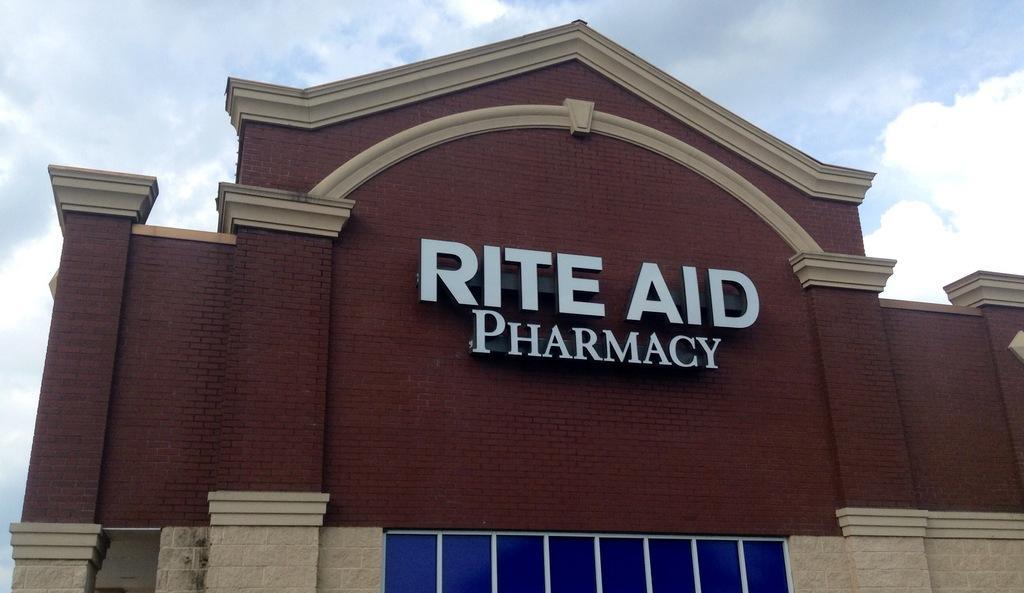Could you give a brief overview of what you see in this image? Here in this picture we can see a building present and on that we can see the name of the building present with a hoarding over there and we can see cloud sin the sky over there. 